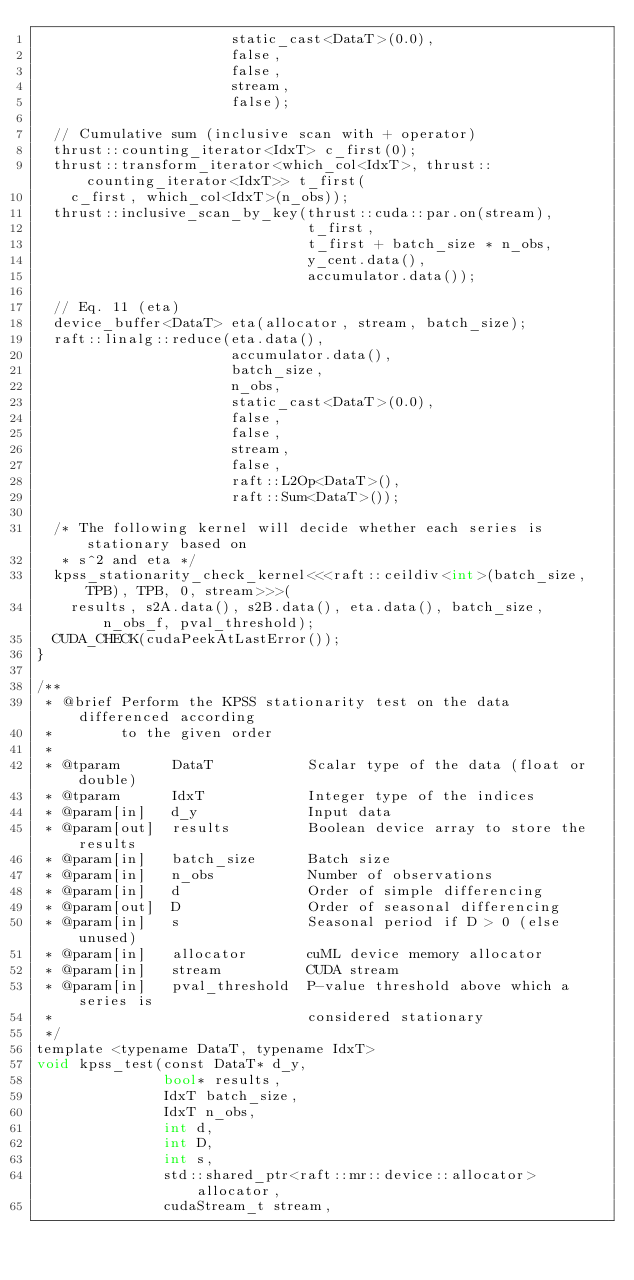Convert code to text. <code><loc_0><loc_0><loc_500><loc_500><_Cuda_>                       static_cast<DataT>(0.0),
                       false,
                       false,
                       stream,
                       false);

  // Cumulative sum (inclusive scan with + operator)
  thrust::counting_iterator<IdxT> c_first(0);
  thrust::transform_iterator<which_col<IdxT>, thrust::counting_iterator<IdxT>> t_first(
    c_first, which_col<IdxT>(n_obs));
  thrust::inclusive_scan_by_key(thrust::cuda::par.on(stream),
                                t_first,
                                t_first + batch_size * n_obs,
                                y_cent.data(),
                                accumulator.data());

  // Eq. 11 (eta)
  device_buffer<DataT> eta(allocator, stream, batch_size);
  raft::linalg::reduce(eta.data(),
                       accumulator.data(),
                       batch_size,
                       n_obs,
                       static_cast<DataT>(0.0),
                       false,
                       false,
                       stream,
                       false,
                       raft::L2Op<DataT>(),
                       raft::Sum<DataT>());

  /* The following kernel will decide whether each series is stationary based on
   * s^2 and eta */
  kpss_stationarity_check_kernel<<<raft::ceildiv<int>(batch_size, TPB), TPB, 0, stream>>>(
    results, s2A.data(), s2B.data(), eta.data(), batch_size, n_obs_f, pval_threshold);
  CUDA_CHECK(cudaPeekAtLastError());
}

/**
 * @brief Perform the KPSS stationarity test on the data differenced according
 *        to the given order
 *
 * @tparam      DataT           Scalar type of the data (float or double)
 * @tparam      IdxT            Integer type of the indices
 * @param[in]   d_y             Input data
 * @param[out]  results         Boolean device array to store the results
 * @param[in]   batch_size      Batch size
 * @param[in]   n_obs           Number of observations
 * @param[in]   d               Order of simple differencing
 * @param[out]  D               Order of seasonal differencing
 * @param[in]   s               Seasonal period if D > 0 (else unused)
 * @param[in]   allocator       cuML device memory allocator
 * @param[in]   stream          CUDA stream
 * @param[in]   pval_threshold  P-value threshold above which a series is
 *                              considered stationary
 */
template <typename DataT, typename IdxT>
void kpss_test(const DataT* d_y,
               bool* results,
               IdxT batch_size,
               IdxT n_obs,
               int d,
               int D,
               int s,
               std::shared_ptr<raft::mr::device::allocator> allocator,
               cudaStream_t stream,</code> 